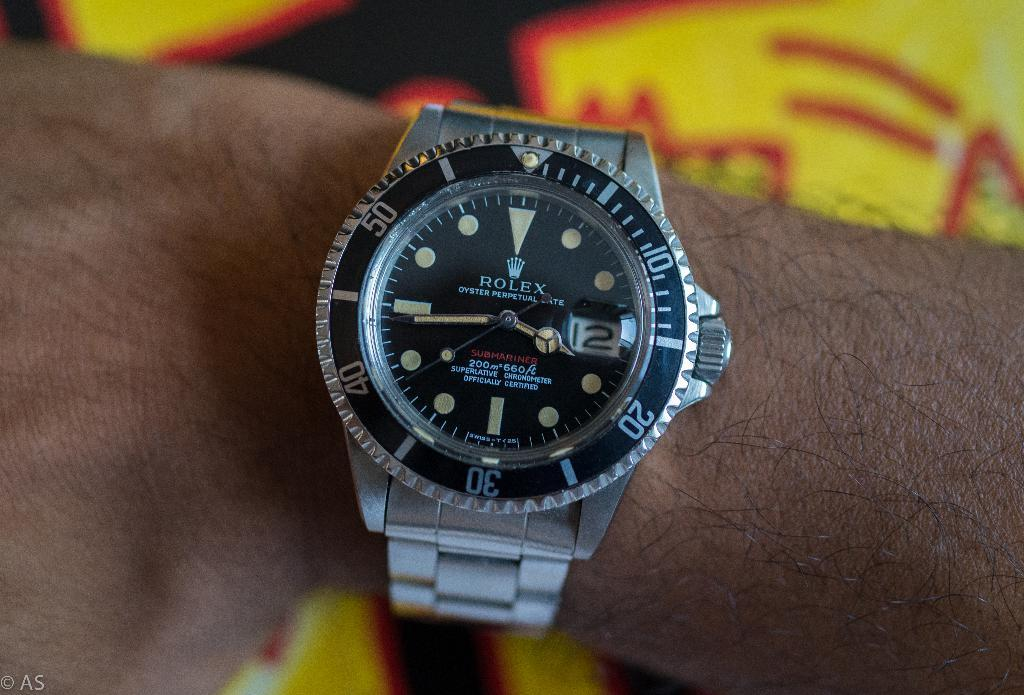<image>
Write a terse but informative summary of the picture. "ROLEX" is shown on the face of the watch. 